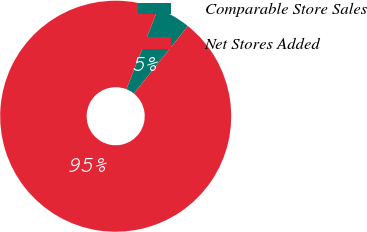Convert chart. <chart><loc_0><loc_0><loc_500><loc_500><pie_chart><fcel>Comparable Store Sales<fcel>Net Stores Added<nl><fcel>4.76%<fcel>95.24%<nl></chart> 